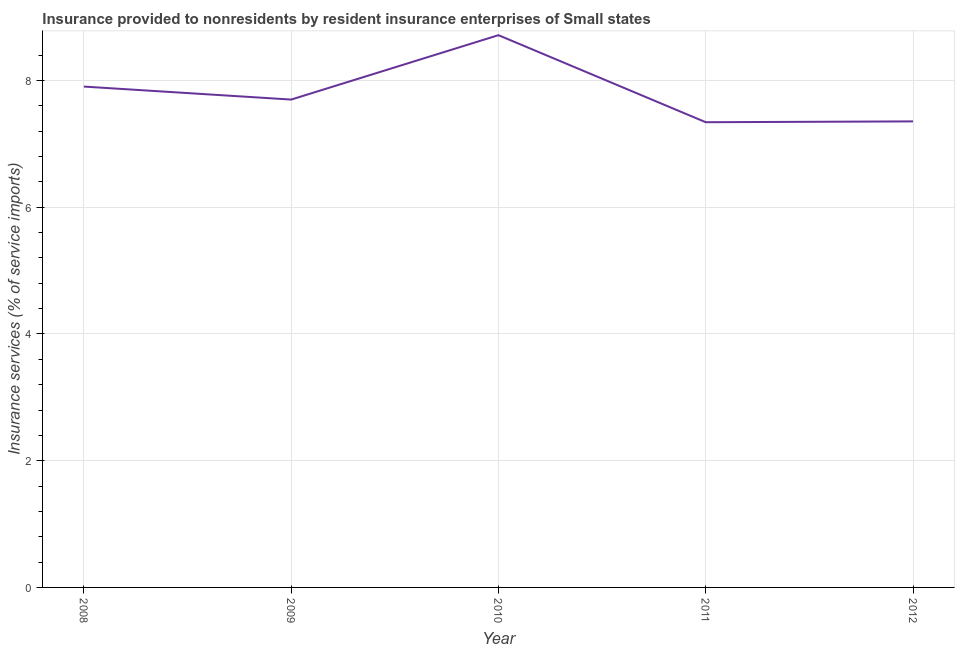What is the insurance and financial services in 2010?
Provide a succinct answer. 8.72. Across all years, what is the maximum insurance and financial services?
Provide a short and direct response. 8.72. Across all years, what is the minimum insurance and financial services?
Offer a very short reply. 7.34. What is the sum of the insurance and financial services?
Ensure brevity in your answer.  39.02. What is the difference between the insurance and financial services in 2009 and 2010?
Ensure brevity in your answer.  -1.02. What is the average insurance and financial services per year?
Offer a very short reply. 7.8. What is the median insurance and financial services?
Your answer should be compact. 7.7. What is the ratio of the insurance and financial services in 2008 to that in 2010?
Keep it short and to the point. 0.91. Is the difference between the insurance and financial services in 2008 and 2012 greater than the difference between any two years?
Your answer should be very brief. No. What is the difference between the highest and the second highest insurance and financial services?
Ensure brevity in your answer.  0.81. What is the difference between the highest and the lowest insurance and financial services?
Make the answer very short. 1.37. In how many years, is the insurance and financial services greater than the average insurance and financial services taken over all years?
Ensure brevity in your answer.  2. How many lines are there?
Offer a very short reply. 1. How many years are there in the graph?
Your answer should be very brief. 5. What is the difference between two consecutive major ticks on the Y-axis?
Your answer should be very brief. 2. Are the values on the major ticks of Y-axis written in scientific E-notation?
Offer a terse response. No. Does the graph contain grids?
Your answer should be compact. Yes. What is the title of the graph?
Make the answer very short. Insurance provided to nonresidents by resident insurance enterprises of Small states. What is the label or title of the Y-axis?
Keep it short and to the point. Insurance services (% of service imports). What is the Insurance services (% of service imports) in 2008?
Your answer should be very brief. 7.91. What is the Insurance services (% of service imports) in 2009?
Your answer should be very brief. 7.7. What is the Insurance services (% of service imports) of 2010?
Provide a succinct answer. 8.72. What is the Insurance services (% of service imports) in 2011?
Offer a very short reply. 7.34. What is the Insurance services (% of service imports) in 2012?
Make the answer very short. 7.36. What is the difference between the Insurance services (% of service imports) in 2008 and 2009?
Provide a succinct answer. 0.2. What is the difference between the Insurance services (% of service imports) in 2008 and 2010?
Offer a very short reply. -0.81. What is the difference between the Insurance services (% of service imports) in 2008 and 2011?
Make the answer very short. 0.56. What is the difference between the Insurance services (% of service imports) in 2008 and 2012?
Provide a short and direct response. 0.55. What is the difference between the Insurance services (% of service imports) in 2009 and 2010?
Offer a terse response. -1.02. What is the difference between the Insurance services (% of service imports) in 2009 and 2011?
Your answer should be very brief. 0.36. What is the difference between the Insurance services (% of service imports) in 2009 and 2012?
Keep it short and to the point. 0.34. What is the difference between the Insurance services (% of service imports) in 2010 and 2011?
Your answer should be compact. 1.37. What is the difference between the Insurance services (% of service imports) in 2010 and 2012?
Keep it short and to the point. 1.36. What is the difference between the Insurance services (% of service imports) in 2011 and 2012?
Your answer should be very brief. -0.01. What is the ratio of the Insurance services (% of service imports) in 2008 to that in 2009?
Your answer should be compact. 1.03. What is the ratio of the Insurance services (% of service imports) in 2008 to that in 2010?
Give a very brief answer. 0.91. What is the ratio of the Insurance services (% of service imports) in 2008 to that in 2011?
Provide a short and direct response. 1.08. What is the ratio of the Insurance services (% of service imports) in 2008 to that in 2012?
Give a very brief answer. 1.07. What is the ratio of the Insurance services (% of service imports) in 2009 to that in 2010?
Offer a terse response. 0.88. What is the ratio of the Insurance services (% of service imports) in 2009 to that in 2011?
Make the answer very short. 1.05. What is the ratio of the Insurance services (% of service imports) in 2009 to that in 2012?
Make the answer very short. 1.05. What is the ratio of the Insurance services (% of service imports) in 2010 to that in 2011?
Make the answer very short. 1.19. What is the ratio of the Insurance services (% of service imports) in 2010 to that in 2012?
Ensure brevity in your answer.  1.19. What is the ratio of the Insurance services (% of service imports) in 2011 to that in 2012?
Your response must be concise. 1. 